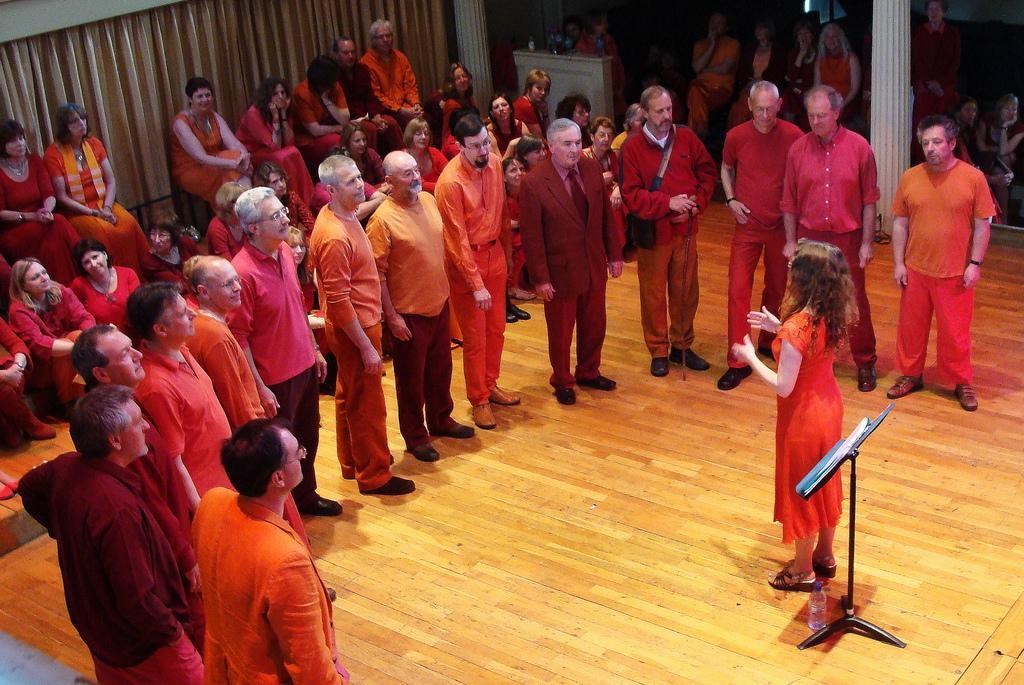Can you describe this image briefly? There are people standing around a lady in the foreground area of the image and the lady is standing near a stand. There are people, curtains, pillars and other objects in the background. 